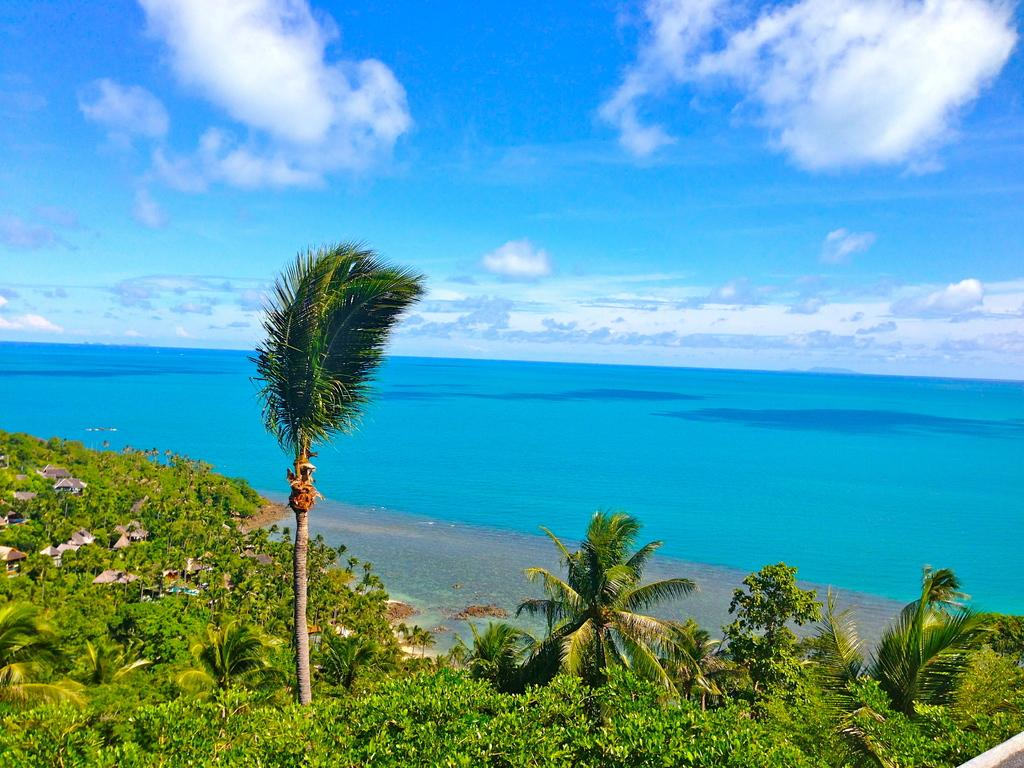What type of vegetation is present at the bottom of the picture? There are trees and plants in the bottom of the picture. What natural feature can be seen in the background of the picture? There is an ocean in the background of the picture. What else is visible in the background of the picture besides the ocean? The sky is visible in the background of the picture. What is the tax rate for the rocks in the picture? There are no rocks present in the image, and therefore no tax rate can be determined. 